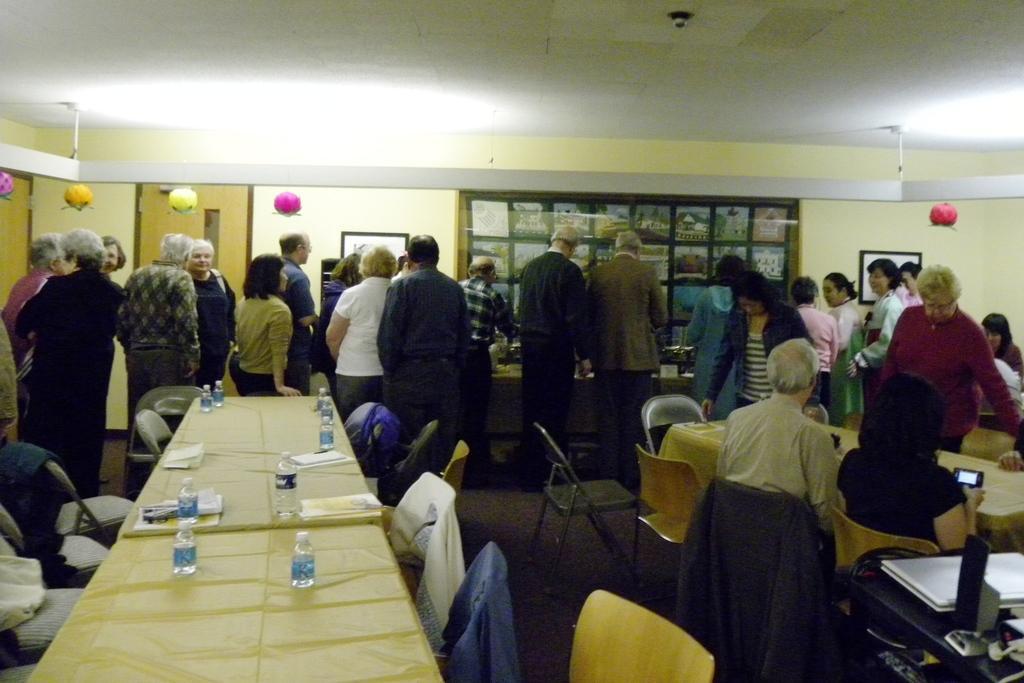Can you describe this image briefly? In the image we can see there are people standing and some of them are sitting, they are wearing clothes. Here we can see a person on the right side of the image, holding a device in the hands. We can see there are many chairs and tables, on the tables we can see water bottles and papers. Here we can see decorative balls, frames stick to the wall and the roof. 